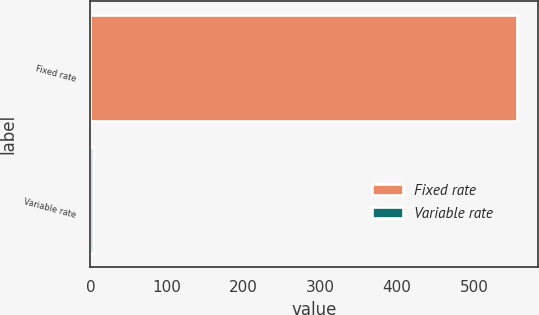<chart> <loc_0><loc_0><loc_500><loc_500><bar_chart><fcel>Fixed rate<fcel>Variable rate<nl><fcel>556.3<fcel>4<nl></chart> 